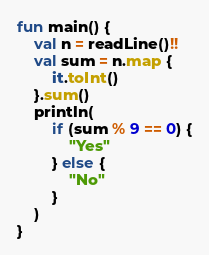Convert code to text. <code><loc_0><loc_0><loc_500><loc_500><_Kotlin_>fun main() {
    val n = readLine()!!
    val sum = n.map {
        it.toInt()
    }.sum()
    println(
        if (sum % 9 == 0) {
            "Yes"
        } else {
            "No"
        }
    )
}</code> 